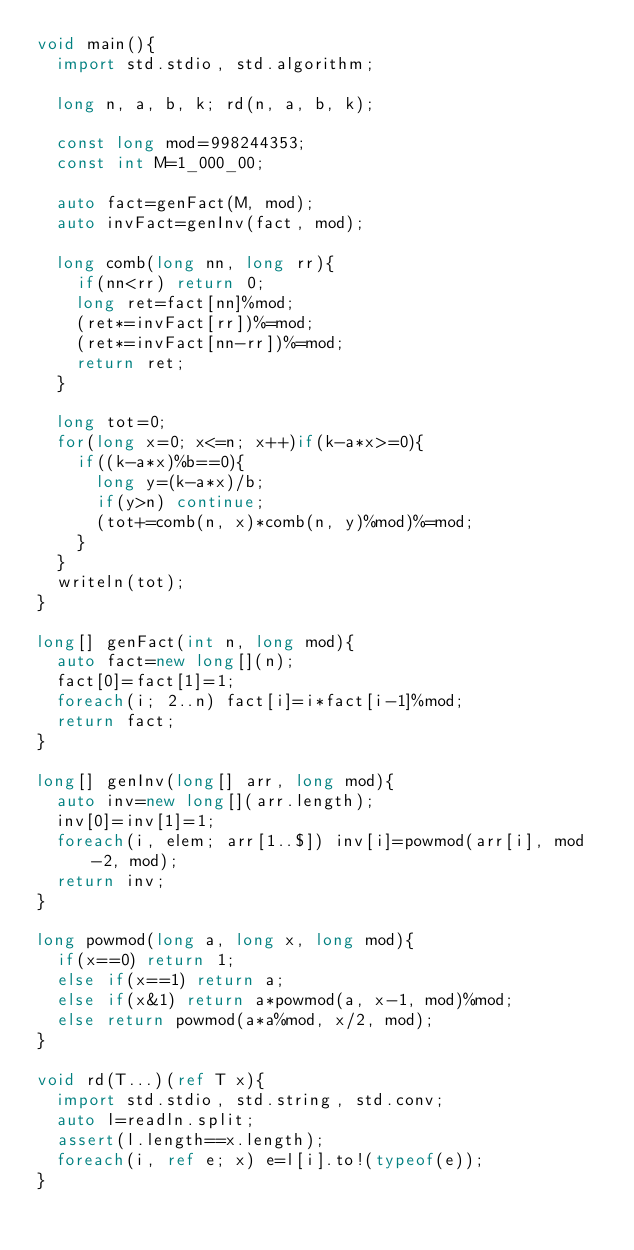Convert code to text. <code><loc_0><loc_0><loc_500><loc_500><_D_>void main(){
  import std.stdio, std.algorithm;
  
  long n, a, b, k; rd(n, a, b, k);

  const long mod=998244353;
  const int M=1_000_00;

  auto fact=genFact(M, mod);
  auto invFact=genInv(fact, mod);

  long comb(long nn, long rr){
    if(nn<rr) return 0;
    long ret=fact[nn]%mod;
    (ret*=invFact[rr])%=mod;
    (ret*=invFact[nn-rr])%=mod;
    return ret;
  }

  long tot=0;
  for(long x=0; x<=n; x++)if(k-a*x>=0){
    if((k-a*x)%b==0){
      long y=(k-a*x)/b;
      if(y>n) continue;
      (tot+=comb(n, x)*comb(n, y)%mod)%=mod;
    }
  }
  writeln(tot);
}

long[] genFact(int n, long mod){
  auto fact=new long[](n);
  fact[0]=fact[1]=1;
  foreach(i; 2..n) fact[i]=i*fact[i-1]%mod;
  return fact;
}

long[] genInv(long[] arr, long mod){
  auto inv=new long[](arr.length);
  inv[0]=inv[1]=1;
  foreach(i, elem; arr[1..$]) inv[i]=powmod(arr[i], mod-2, mod);
  return inv;
}

long powmod(long a, long x, long mod){
  if(x==0) return 1;
  else if(x==1) return a;
  else if(x&1) return a*powmod(a, x-1, mod)%mod;
  else return powmod(a*a%mod, x/2, mod);
}

void rd(T...)(ref T x){
  import std.stdio, std.string, std.conv;
  auto l=readln.split;
  assert(l.length==x.length);
  foreach(i, ref e; x) e=l[i].to!(typeof(e));
}
</code> 